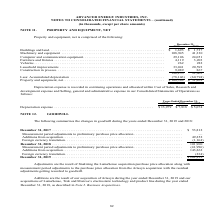According to Advanced Energy's financial document, What was the amount for buildings and land in 2019? According to the financial document, $1,693 (in thousands). The relevant text states: "Buildings and land . $ 1,693 $ 1,737..." Also, What was the amount for Machinery and equipment in 2018? According to the financial document, 41,330 (in thousands). The relevant text states: "Machinery and equipment . 108,945 41,330 Computer and communication equipment . 29,106 24,051 Furniture and fixtures . 4,119 3,203 Vehicles..." Also, What was the amount of Computer and communication equipment in 2019? According to the financial document, 29,106 (in thousands). The relevant text states: "945 41,330 Computer and communication equipment . 29,106 24,051 Furniture and fixtures . 4,119 3,203 Vehicles . 262 282 Leasehold improvements . 33,041 20,5..." Also, can you calculate: What was the sum of the three highest property and equipment in 2019? Based on the calculation: 108,945+29,106+33,041, the result is 171092 (in thousands). This is based on the information: "Machinery and equipment . 108,945 41,330 Computer and communication equipment . 29,106 24,051 Furniture and fixtures . 4,119 3,203 Ve 945 41,330 Computer and communication equipment . 29,106 24,051 Fu..." The key data points involved are: 108,945, 29,106, 33,041. Additionally, What are the three highest property and equipment components in 2018? The document contains multiple relevant values: Machinery and equipment, Computer and communication equipment, Leasehold improvements. From the document: "Machinery and equipment . 108,945 41,330 Computer and communication equipment . 29,106 24,051 Furniture and fixtures . 4,119 3,203 Vehicles . 262 282 ..." Also, can you calculate: What was the percentage change in the net property and equipment between 2018 and 2019? To answer this question, I need to perform calculations using the financial data. The calculation is: ($108,109-$31,269)/$31,269, which equals 245.74 (percentage). This is based on the information: "(78,146) (60,794) Property and equipment, net . $ 108,109 $ 31,269 Depreciation expense is recorded in continuing operations and allocated within Cost of Sal 60,794) Property and equipment, net . $ 10..." The key data points involved are: 108,109, 31,269. 